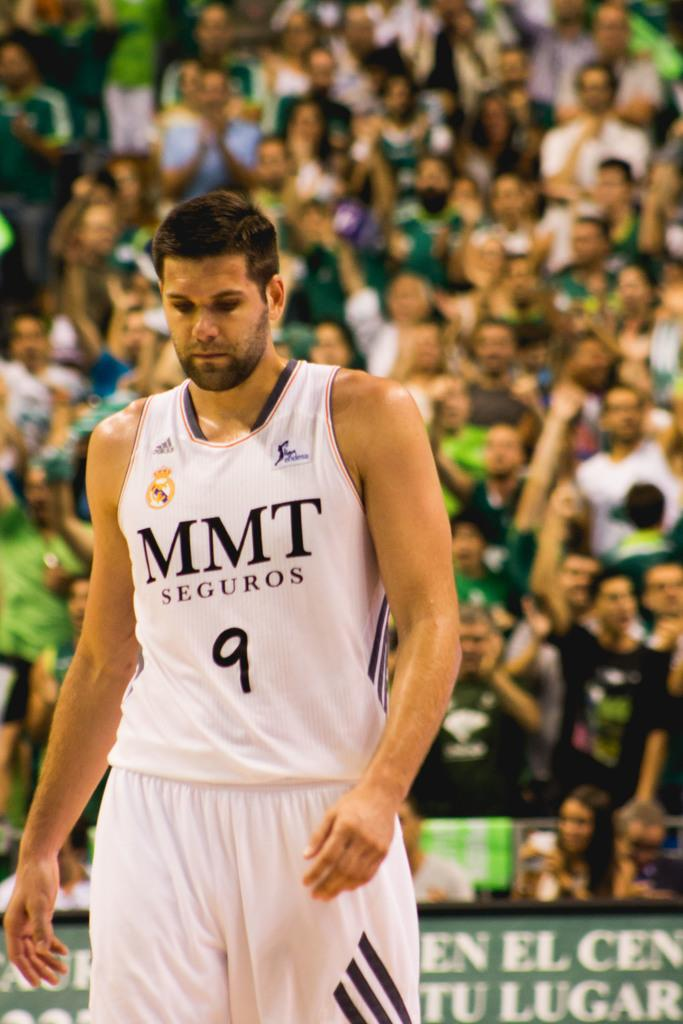<image>
Provide a brief description of the given image. A basketball player has the black letters of MMT on front of his white jersey. 